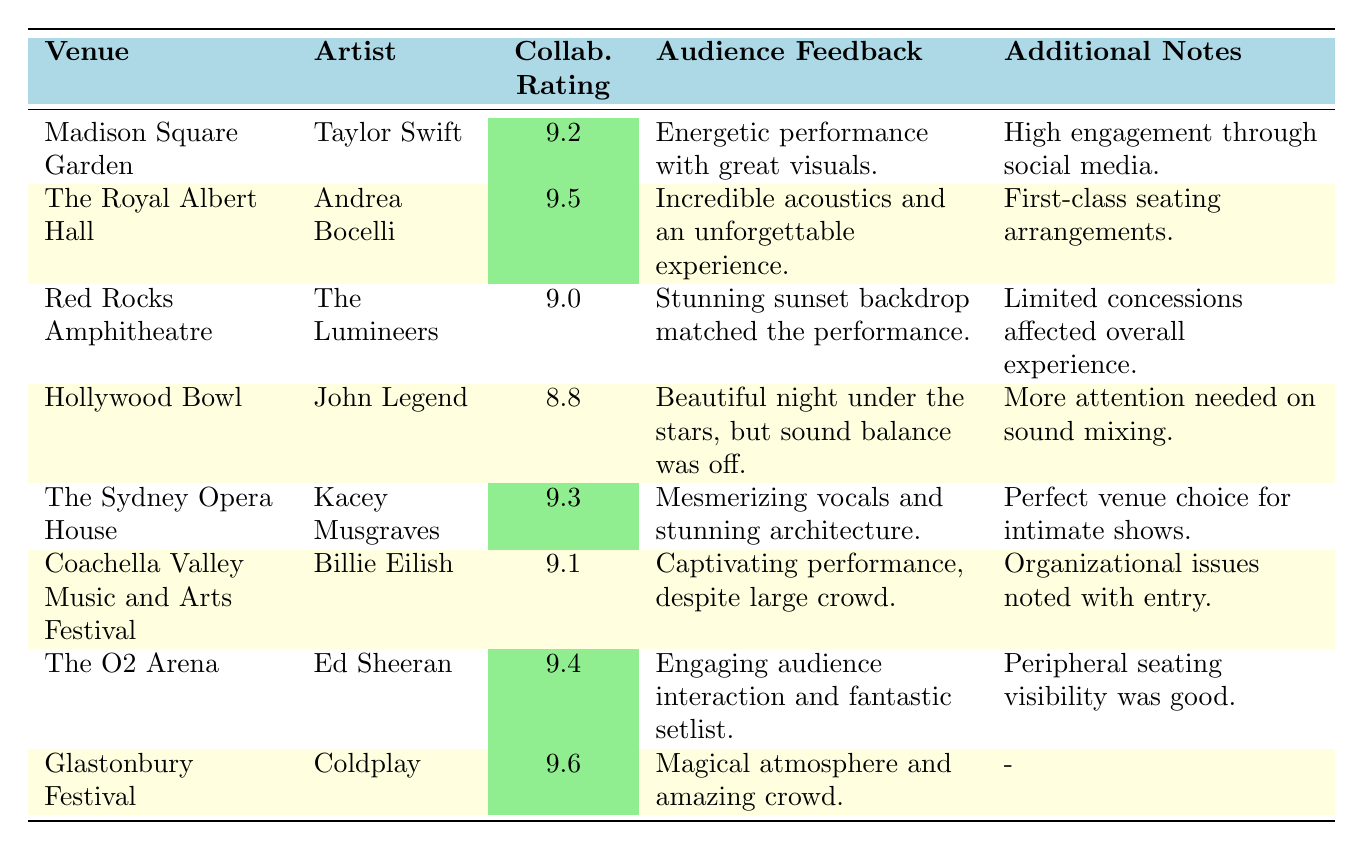What is the highest collaboration rating among the venues listed? The collaboration ratings for the venues are 9.2, 9.5, 9.0, 8.8, 9.3, 9.1, 9.4, and 9.6. The highest value is 9.6, associated with Coldplay at Glastonbury Festival.
Answer: 9.6 Which artist performed at The Royal Albert Hall? The venue The Royal Albert Hall is associated with Andrea Bocelli.
Answer: Andrea Bocelli What is the average collaboration rating of the venues listed? To find the average, add the ratings (9.2 + 9.5 + 9.0 + 8.8 + 9.3 + 9.1 + 9.4 + 9.6) = 73.5, then divide by the number of venues (8). So, the average is 73.5/8 = 9.1875, which rounds to 9.19.
Answer: 9.19 Did any artist receive a collaboration rating lower than 9.0? The ratings listed are 9.2, 9.5, 9.0, 8.8, 9.3, 9.1, 9.4, and 9.6. The only rating below 9.0 is 8.8 from John Legend at Hollywood Bowl.
Answer: Yes Which venue had the highest audience feedback quality according to the comments? The comments reflect quality through descriptors like "incredible," "captivating," and "magical." The Royal Albert Hall mentioned "Incredible acoustics," and Glastonbury Festival mentioned "Magical atmosphere." However, the highest rating of 9.6 correlates with Coldplay at Glastonbury, suggesting the highest overall satisfaction.
Answer: Glastonbury Festival Was there any mention of sound quality issues relating to any performance? Yes, under the Hollywood Bowl, the feedback noted that "sound balance was off," indicating an issue with sound quality during John Legend's performance.
Answer: Yes How many venues have collaboration ratings above 9.3? The ratings above 9.3 are 9.4 (Ed Sheeran), 9.5 (Andrea Bocelli), and 9.6 (Coldplay). This gives us a total of 3 venues.
Answer: 3 What additional note was provided for Coachella Valley Music and Arts Festival? The additional note states "Organizational issues noted with entry," suggesting logistical challenges encountered during the festival.
Answer: Organizational issues noted with entry Which venue provided the best "audience feedback" according to the table? The feedback for Glastonbury Festival describes the atmosphere as "magical" and the crowd as "amazing," which are very positive descriptors. Among all feedback, it stands out as highly positive and memorable.
Answer: Glastonbury Festival What feedback did the audience provide regarding The Lumineers' performance? The feedback states, "Stunning sunset backdrop matched the performance," which highlights the visual appeal and connection to the performance during The Lumineers' show.
Answer: Stunning sunset backdrop matched the performance 